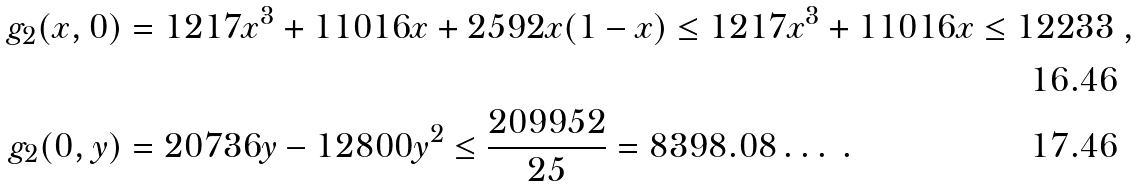Convert formula to latex. <formula><loc_0><loc_0><loc_500><loc_500>g _ { 2 } ( x , 0 ) & = 1 2 1 7 x ^ { 3 } + 1 1 0 1 6 x + 2 5 9 2 x ( 1 - x ) \leq 1 2 1 7 x ^ { 3 } + 1 1 0 1 6 x \leq 1 2 2 3 3 \ , \\ g _ { 2 } ( 0 , y ) & = 2 0 7 3 6 y - 1 2 8 0 0 y ^ { 2 } \leq \frac { 2 0 9 9 5 2 } { 2 5 } = 8 3 9 8 . 0 8 \dots \ .</formula> 